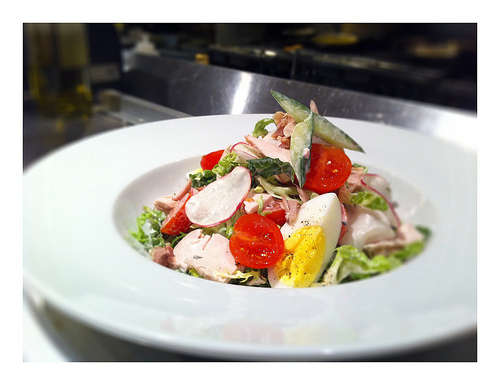<image>
Can you confirm if the bowl is in the vegetables? No. The bowl is not contained within the vegetables. These objects have a different spatial relationship. Where is the bowl in relation to the table? Is it above the table? Yes. The bowl is positioned above the table in the vertical space, higher up in the scene. 